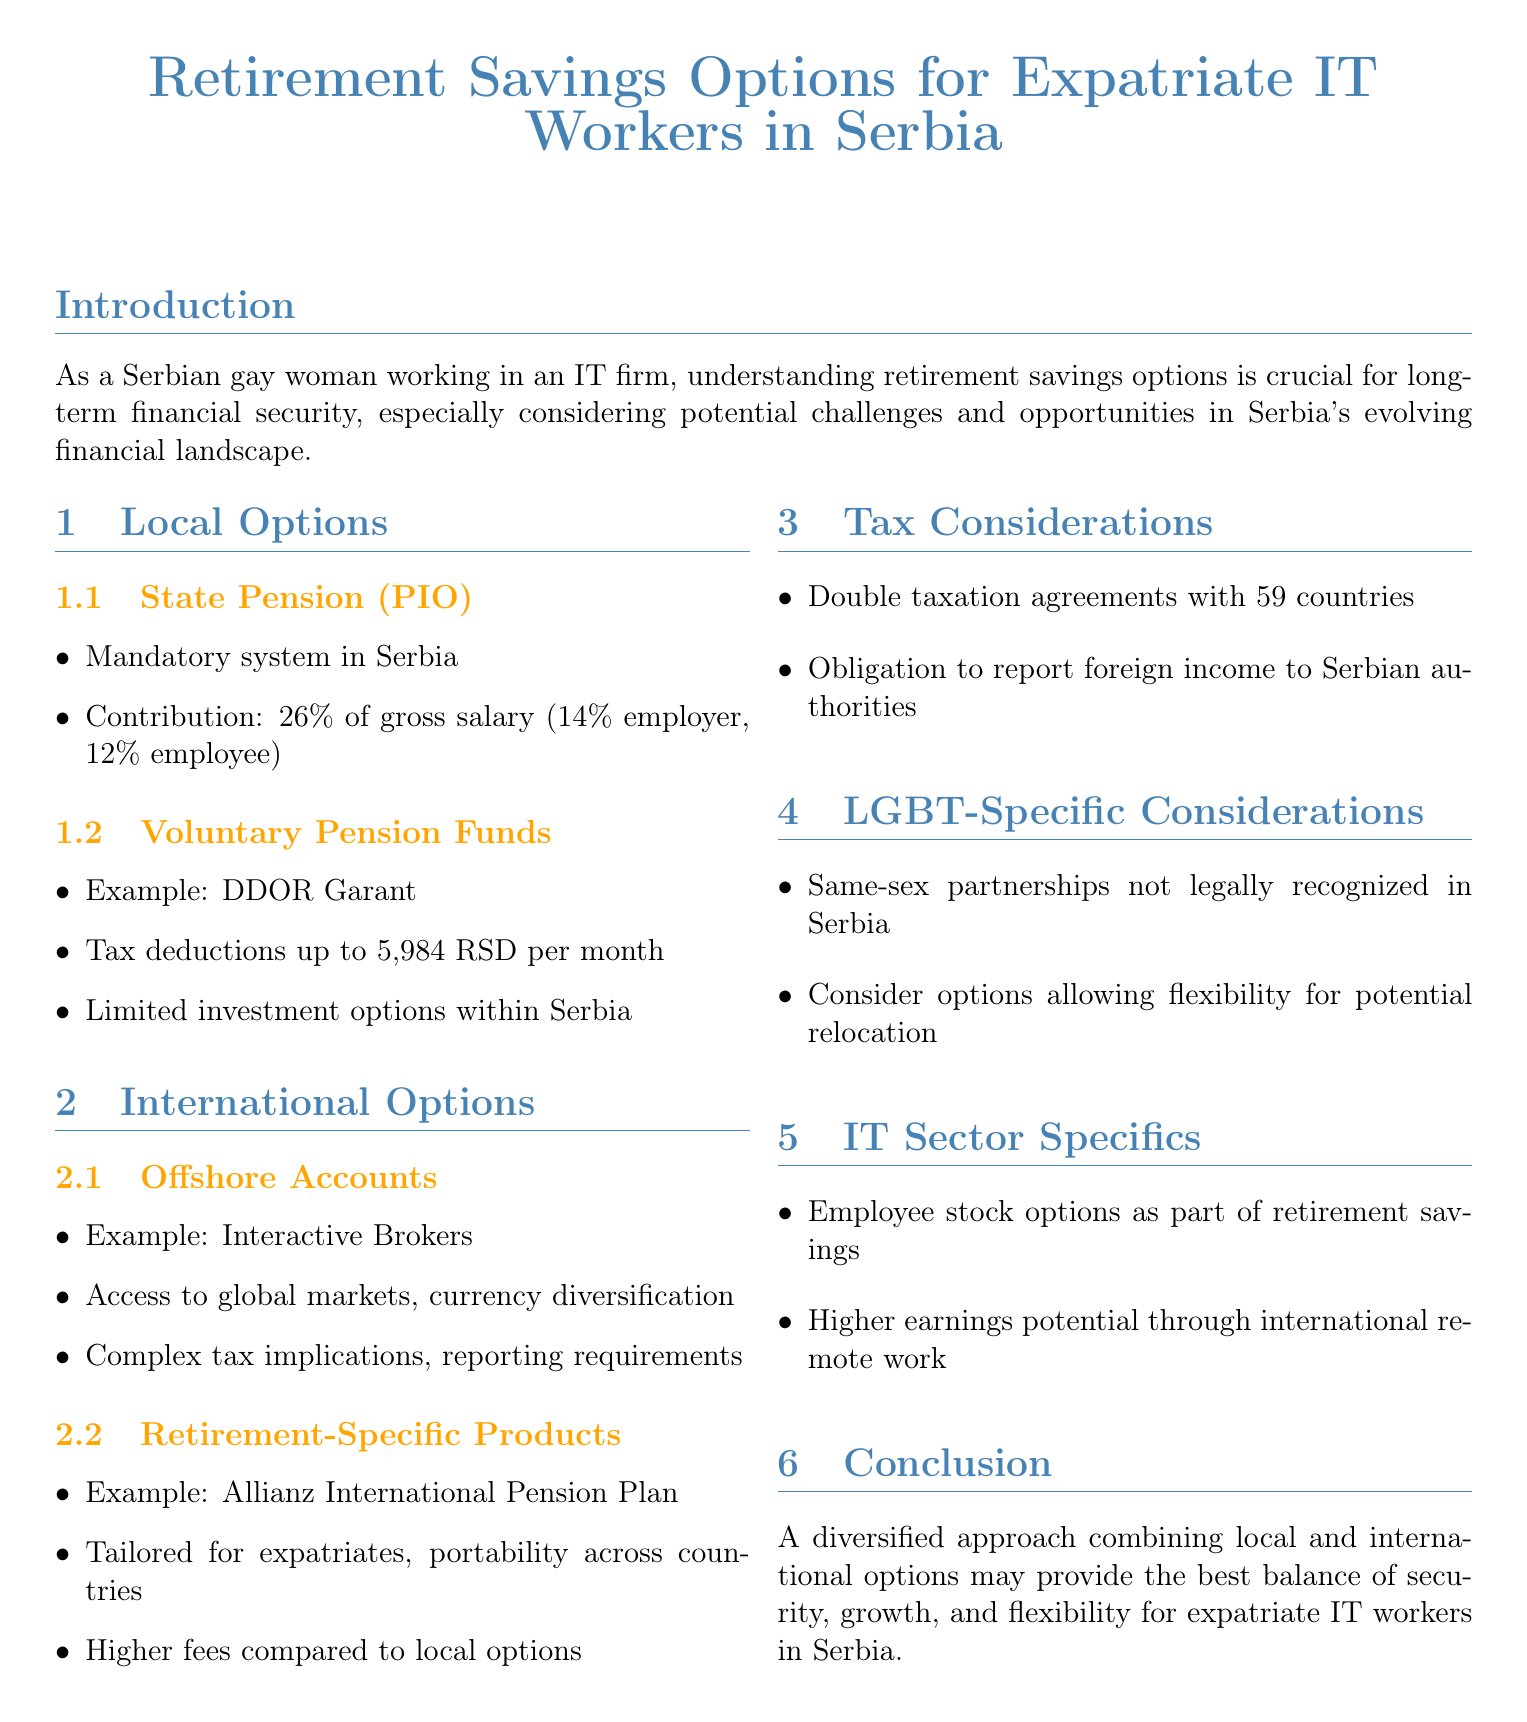What is the contribution rate for the state pension in Serbia? The contribution rate for the state pension system is 26% of gross salary, consisting of 14% by the employer and 12% by the employee.
Answer: 26% What is an example of a voluntary pension fund in Serbia? The document mentions that an example of a voluntary pension fund is DDOR Garant.
Answer: DDOR Garant What are the benefits of using an offshore account? The benefits include access to global markets and currency diversification.
Answer: Access to global markets, currency diversification What is a key takeaway from the report? A key takeaway is the recommendation for a diversified approach combining local and international options.
Answer: A diversified approach How many countries does Serbia have double taxation agreements with? The document states that Serbia has agreements with 59 countries to prevent double taxation.
Answer: 59 What potential impact does the legal status of same-sex partnerships have? The legal status of same-sex partnerships affects inheritance and beneficiary designations.
Answer: Inheritance and beneficiary designations What specific investment option can be significant for retirement savings in the IT sector? The document mentions that employee stock options can be a significant part of retirement savings.
Answer: Employee stock options What is a consideration when opting for retirement-specific products? The document states that retirement-specific products often have higher fees compared to local options.
Answer: Higher fees 